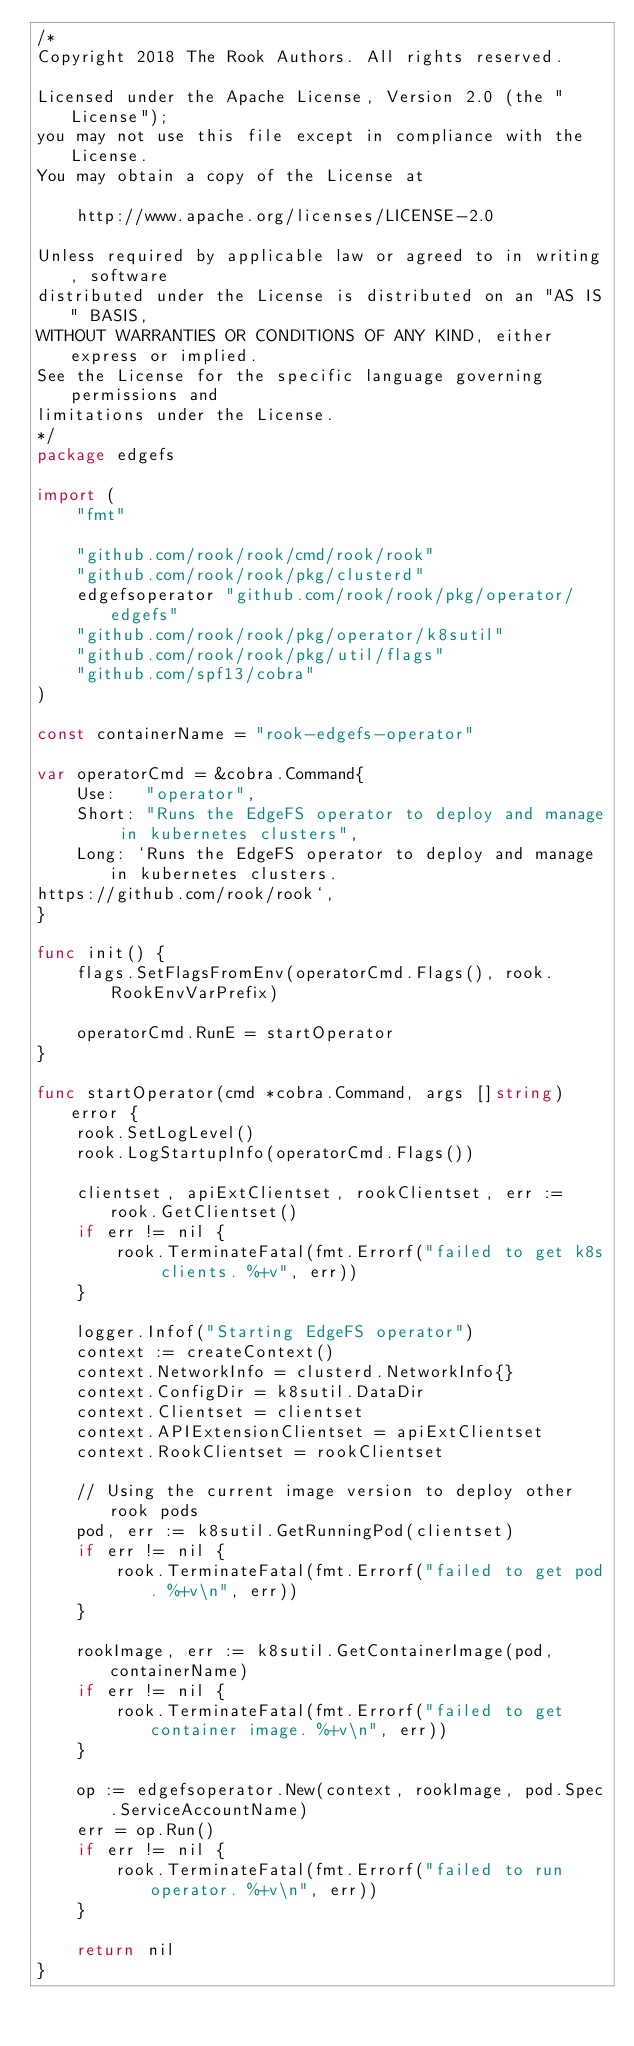Convert code to text. <code><loc_0><loc_0><loc_500><loc_500><_Go_>/*
Copyright 2018 The Rook Authors. All rights reserved.

Licensed under the Apache License, Version 2.0 (the "License");
you may not use this file except in compliance with the License.
You may obtain a copy of the License at

	http://www.apache.org/licenses/LICENSE-2.0

Unless required by applicable law or agreed to in writing, software
distributed under the License is distributed on an "AS IS" BASIS,
WITHOUT WARRANTIES OR CONDITIONS OF ANY KIND, either express or implied.
See the License for the specific language governing permissions and
limitations under the License.
*/
package edgefs

import (
	"fmt"

	"github.com/rook/rook/cmd/rook/rook"
	"github.com/rook/rook/pkg/clusterd"
	edgefsoperator "github.com/rook/rook/pkg/operator/edgefs"
	"github.com/rook/rook/pkg/operator/k8sutil"
	"github.com/rook/rook/pkg/util/flags"
	"github.com/spf13/cobra"
)

const containerName = "rook-edgefs-operator"

var operatorCmd = &cobra.Command{
	Use:   "operator",
	Short: "Runs the EdgeFS operator to deploy and manage in kubernetes clusters",
	Long: `Runs the EdgeFS operator to deploy and manage in kubernetes clusters.
https://github.com/rook/rook`,
}

func init() {
	flags.SetFlagsFromEnv(operatorCmd.Flags(), rook.RookEnvVarPrefix)

	operatorCmd.RunE = startOperator
}

func startOperator(cmd *cobra.Command, args []string) error {
	rook.SetLogLevel()
	rook.LogStartupInfo(operatorCmd.Flags())

	clientset, apiExtClientset, rookClientset, err := rook.GetClientset()
	if err != nil {
		rook.TerminateFatal(fmt.Errorf("failed to get k8s clients. %+v", err))
	}

	logger.Infof("Starting EdgeFS operator")
	context := createContext()
	context.NetworkInfo = clusterd.NetworkInfo{}
	context.ConfigDir = k8sutil.DataDir
	context.Clientset = clientset
	context.APIExtensionClientset = apiExtClientset
	context.RookClientset = rookClientset

	// Using the current image version to deploy other rook pods
	pod, err := k8sutil.GetRunningPod(clientset)
	if err != nil {
		rook.TerminateFatal(fmt.Errorf("failed to get pod. %+v\n", err))
	}

	rookImage, err := k8sutil.GetContainerImage(pod, containerName)
	if err != nil {
		rook.TerminateFatal(fmt.Errorf("failed to get container image. %+v\n", err))
	}

	op := edgefsoperator.New(context, rookImage, pod.Spec.ServiceAccountName)
	err = op.Run()
	if err != nil {
		rook.TerminateFatal(fmt.Errorf("failed to run operator. %+v\n", err))
	}

	return nil
}
</code> 